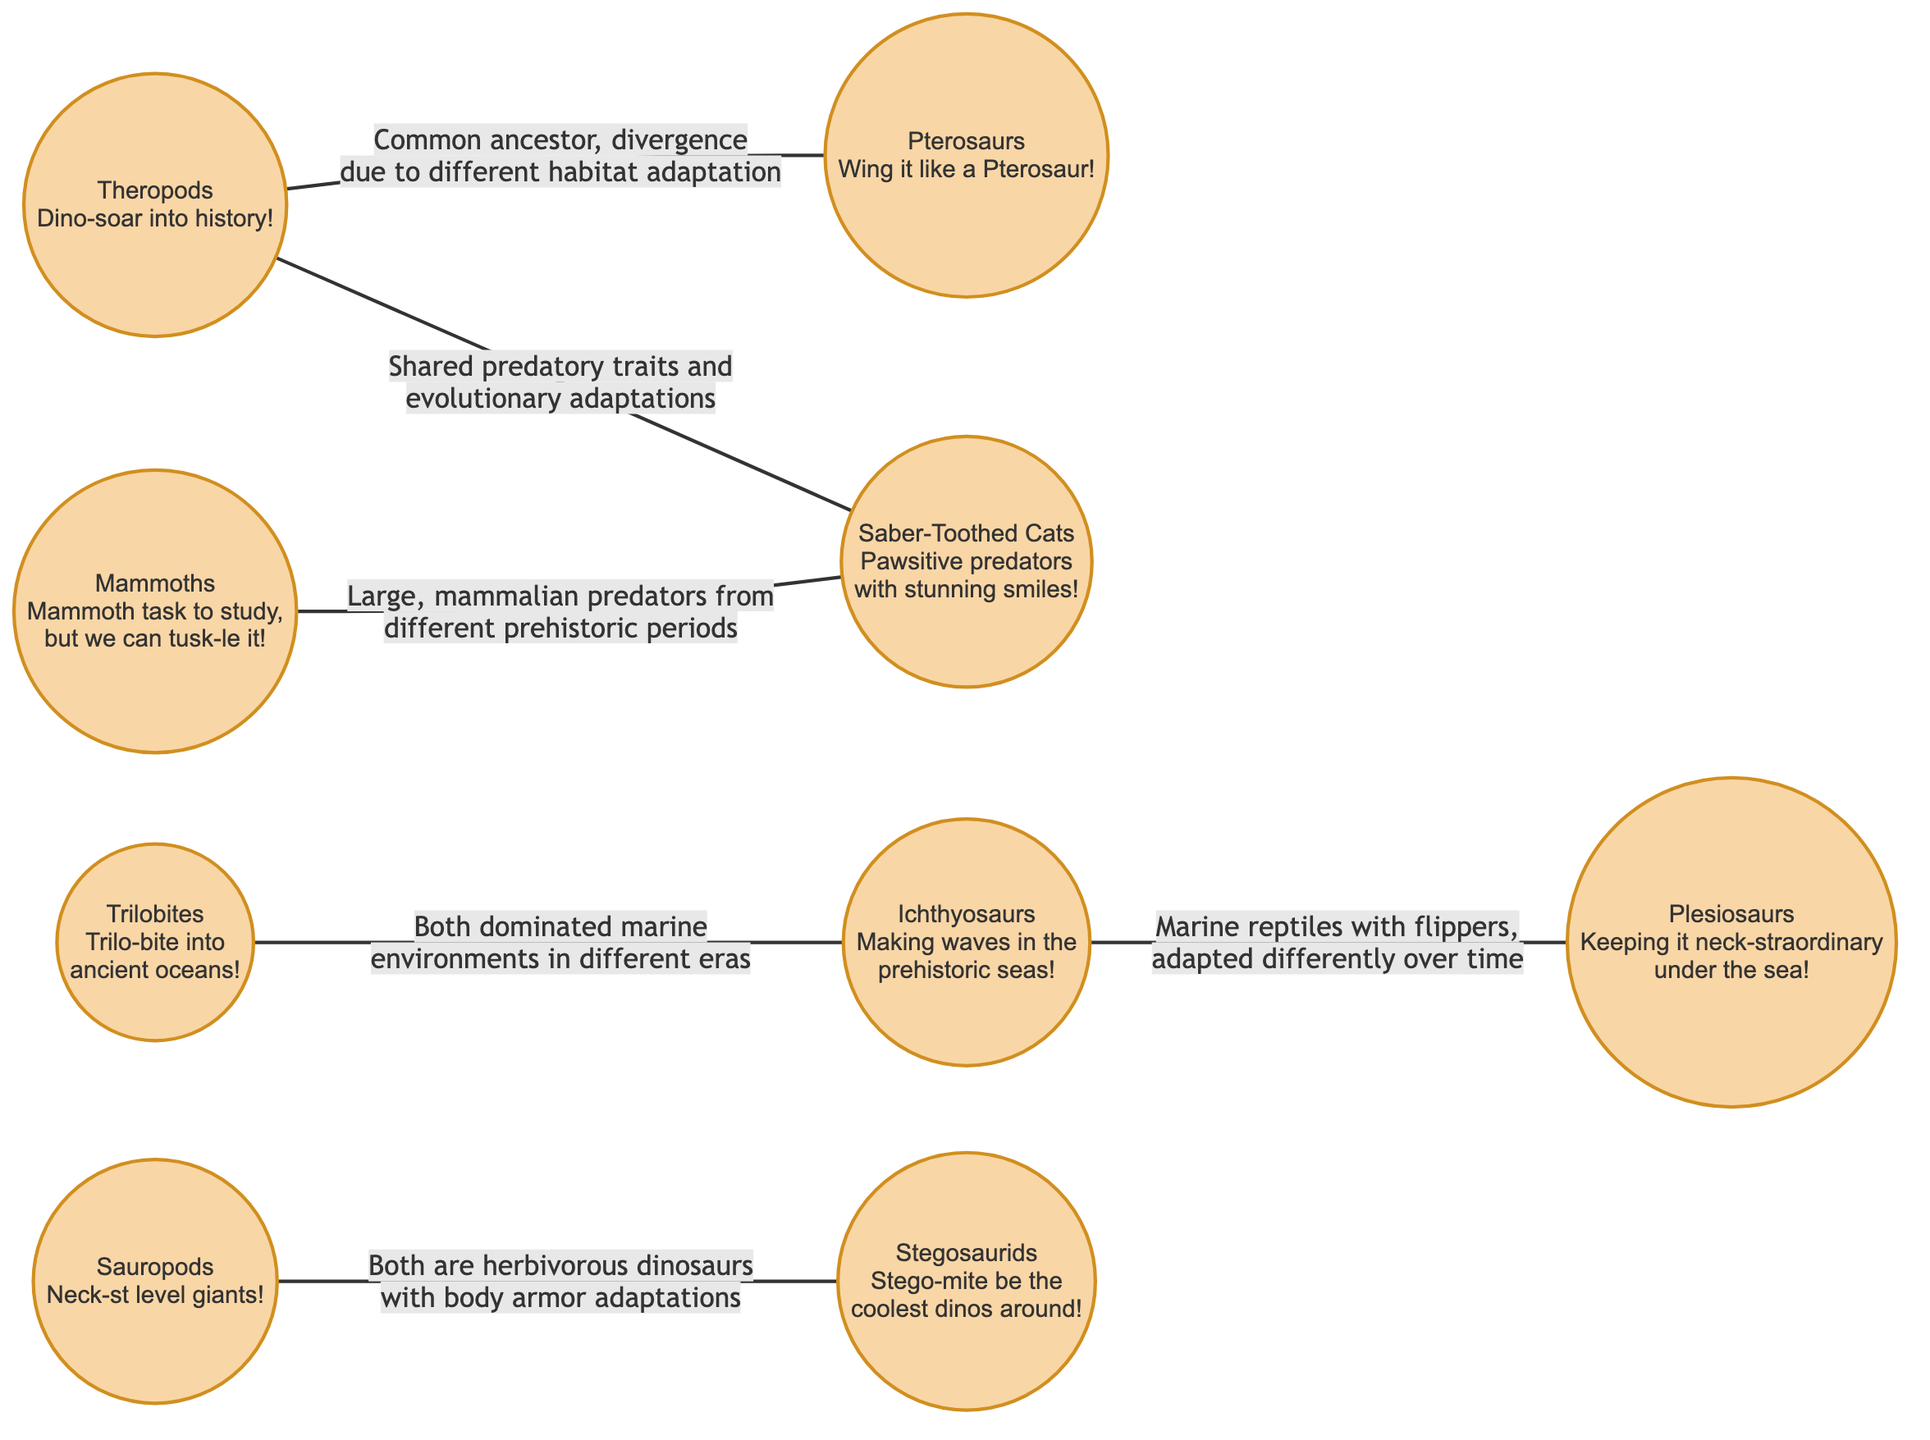What is the total number of nodes in the diagram? The diagram clearly shows 9 distinct prehistoric animals represented as nodes. Therefore, counting each unique node results in a total of 9 nodes.
Answer: 9 Which two groups share a common ancestor as depicted in the diagram? According to the link between nodes, Theropods and Pterosaurs diverged from a common ancestor, indicating they share this ancestral relationship directly stated in the diagram.
Answer: Theropods and Pterosaurs What adaptation connects Sauropods and Stegosaurids? The link between Sauropods and Stegosaurids states that both groups have body armor adaptations, highlighting their shared characteristics as herbivorous dinosaurs in the diagram.
Answer: Body armor adaptations How many marine reptile connections are shown in the diagram? The diagram demonstrates two notable connections of marine reptiles: one linking Ichthyosaurs to Trilobites and another linking Ichthyosaurs to Plesiosaurs, leading to a total of two connections specifically involving marine reptiles.
Answer: 2 What do Mammoths and Saber-Toothed Cats have in common according to the diagram? The diagram indicates that Mammoths and Saber-Toothed Cats are both large mammalian predators but from different prehistoric periods, highlighting their shared predatory traits.
Answer: Large mammalian predators Which two groups diverged due to habitat adaptation? The connection from Theropods to Pterosaurs indicates that their divergence is due to different habitat adaptations, framing their evolutionary relationship in the diagram.
Answer: Theropods and Pterosaurs What type of animals are represented by the nodes 6 and 7? Nodes 6 and 7 represent Trilobites and Ichthyosaurs respectively, both of which are marine creatures that dominated their respective environments, as specified in the diagram.
Answer: Marine creatures Which nodes are herbivorous dinosaurs according to the links? The nodes labeled Sauropods and Stegosaurids are both linked in the diagram as herbivorous dinosaurs, illustrating their dietary similarities with distinct adaptations.
Answer: Sauropods and Stegosaurids 